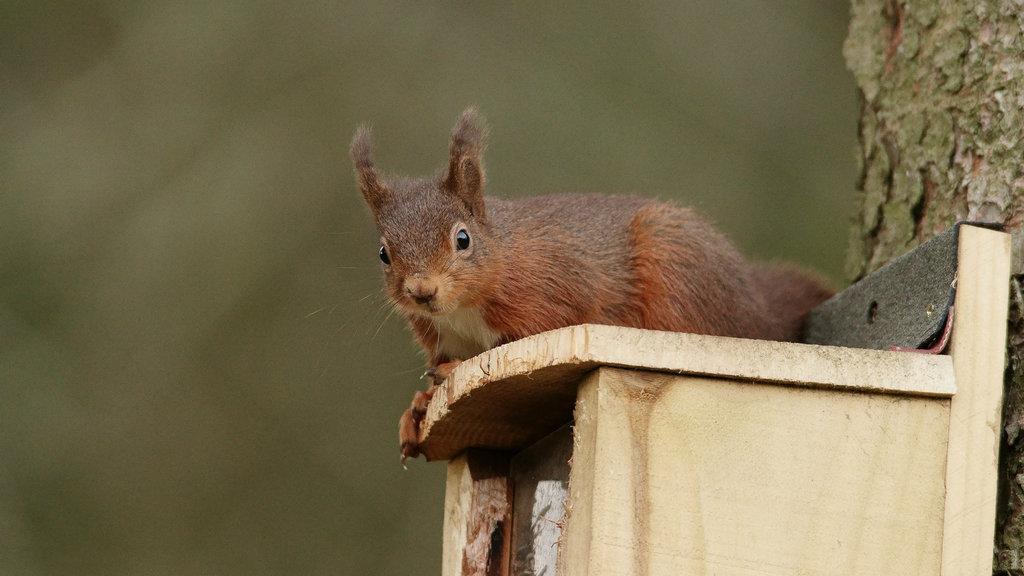In one or two sentences, can you explain what this image depicts? In this image I can see a rabbit on a bench, tree trunk and the background is not clear. This image is taken may be during a day. 